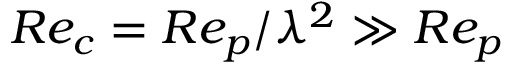Convert formula to latex. <formula><loc_0><loc_0><loc_500><loc_500>R e _ { c } = R e _ { p } / \lambda ^ { 2 } \gg R e _ { p }</formula> 